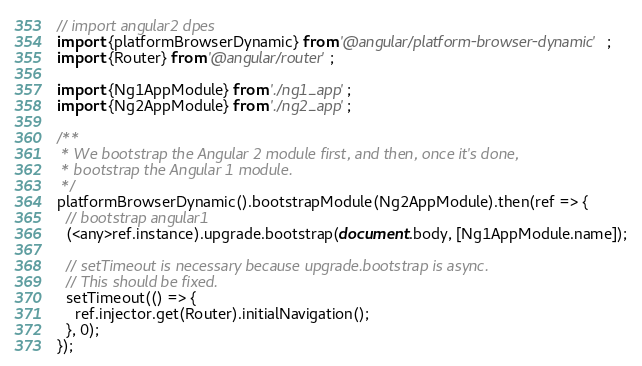<code> <loc_0><loc_0><loc_500><loc_500><_TypeScript_>// import angular2 dpes
import {platformBrowserDynamic} from '@angular/platform-browser-dynamic';
import {Router} from '@angular/router';

import {Ng1AppModule} from './ng1_app';
import {Ng2AppModule} from './ng2_app';

/**
 * We bootstrap the Angular 2 module first, and then, once it's done,
 * bootstrap the Angular 1 module.
 */
platformBrowserDynamic().bootstrapModule(Ng2AppModule).then(ref => {
  // bootstrap angular1
  (<any>ref.instance).upgrade.bootstrap(document.body, [Ng1AppModule.name]);

  // setTimeout is necessary because upgrade.bootstrap is async.
  // This should be fixed.
  setTimeout(() => {
    ref.injector.get(Router).initialNavigation();
  }, 0);
});
</code> 